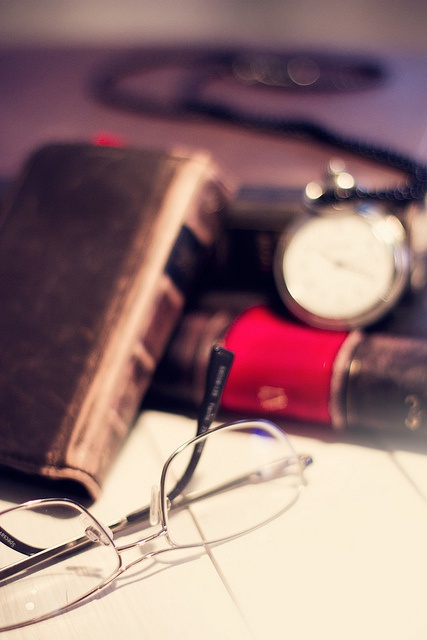Describe the objects in this image and their specific colors. I can see book in gray, black, brown, and tan tones, book in gray, black, brown, and red tones, and clock in gray, beige, and tan tones in this image. 